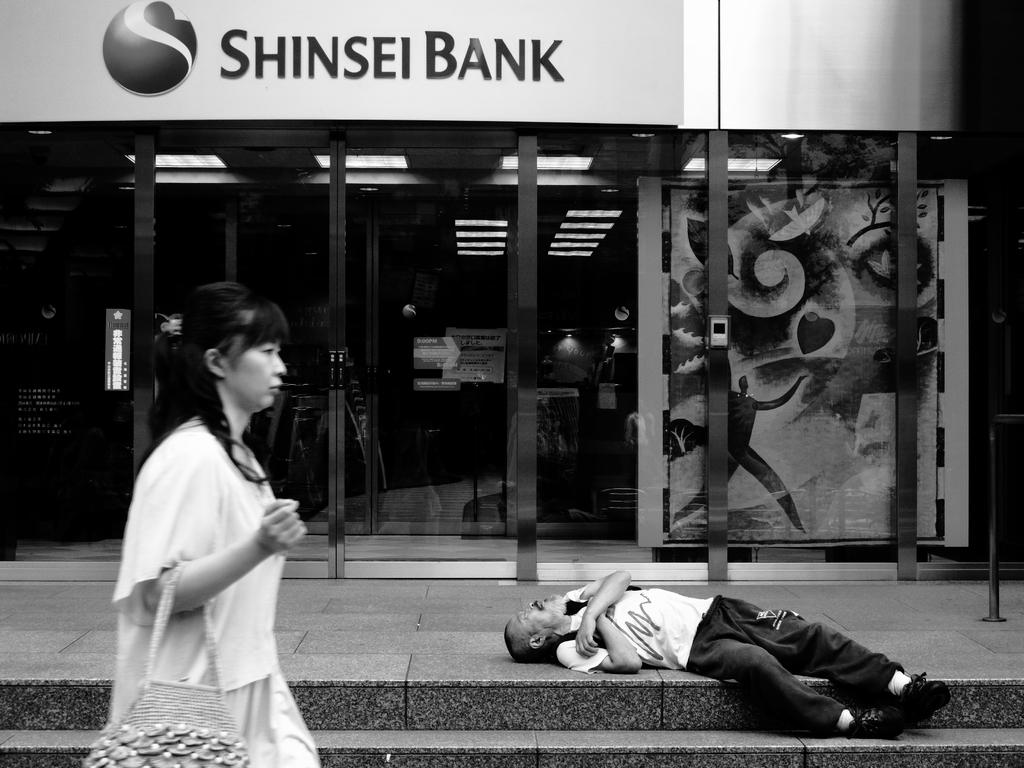What is the color scheme of the image? The image is black and white. What type of building is in the image? There is a bank in the image. What is happening in front of the bank? A person is lying on the floor in front of the bank. Is there anyone else in the image besides the person on the floor? Yes, there is a woman passing by the scene. What type of plantation is visible in the image? There is no plantation present in the image. What system is being used to manage the bank in the image? The image does not provide information about the bank's management system. 